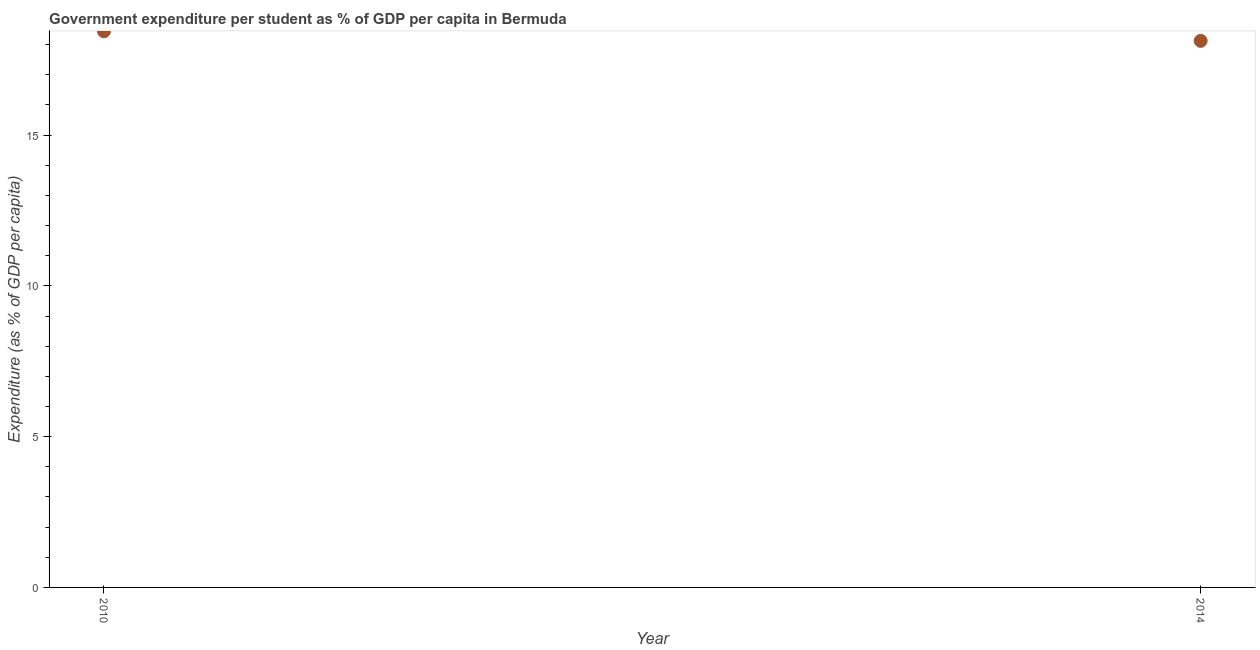What is the government expenditure per student in 2010?
Make the answer very short. 18.44. Across all years, what is the maximum government expenditure per student?
Provide a short and direct response. 18.44. Across all years, what is the minimum government expenditure per student?
Offer a terse response. 18.12. In which year was the government expenditure per student maximum?
Provide a succinct answer. 2010. What is the sum of the government expenditure per student?
Provide a short and direct response. 36.56. What is the difference between the government expenditure per student in 2010 and 2014?
Provide a short and direct response. 0.32. What is the average government expenditure per student per year?
Give a very brief answer. 18.28. What is the median government expenditure per student?
Keep it short and to the point. 18.28. In how many years, is the government expenditure per student greater than 9 %?
Offer a very short reply. 2. What is the ratio of the government expenditure per student in 2010 to that in 2014?
Offer a very short reply. 1.02. Is the government expenditure per student in 2010 less than that in 2014?
Provide a short and direct response. No. In how many years, is the government expenditure per student greater than the average government expenditure per student taken over all years?
Offer a terse response. 1. Does the government expenditure per student monotonically increase over the years?
Ensure brevity in your answer.  No. How many dotlines are there?
Your answer should be compact. 1. How many years are there in the graph?
Give a very brief answer. 2. Are the values on the major ticks of Y-axis written in scientific E-notation?
Offer a terse response. No. Does the graph contain any zero values?
Provide a short and direct response. No. Does the graph contain grids?
Offer a terse response. No. What is the title of the graph?
Give a very brief answer. Government expenditure per student as % of GDP per capita in Bermuda. What is the label or title of the X-axis?
Give a very brief answer. Year. What is the label or title of the Y-axis?
Give a very brief answer. Expenditure (as % of GDP per capita). What is the Expenditure (as % of GDP per capita) in 2010?
Your answer should be compact. 18.44. What is the Expenditure (as % of GDP per capita) in 2014?
Your response must be concise. 18.12. What is the difference between the Expenditure (as % of GDP per capita) in 2010 and 2014?
Your answer should be very brief. 0.32. 